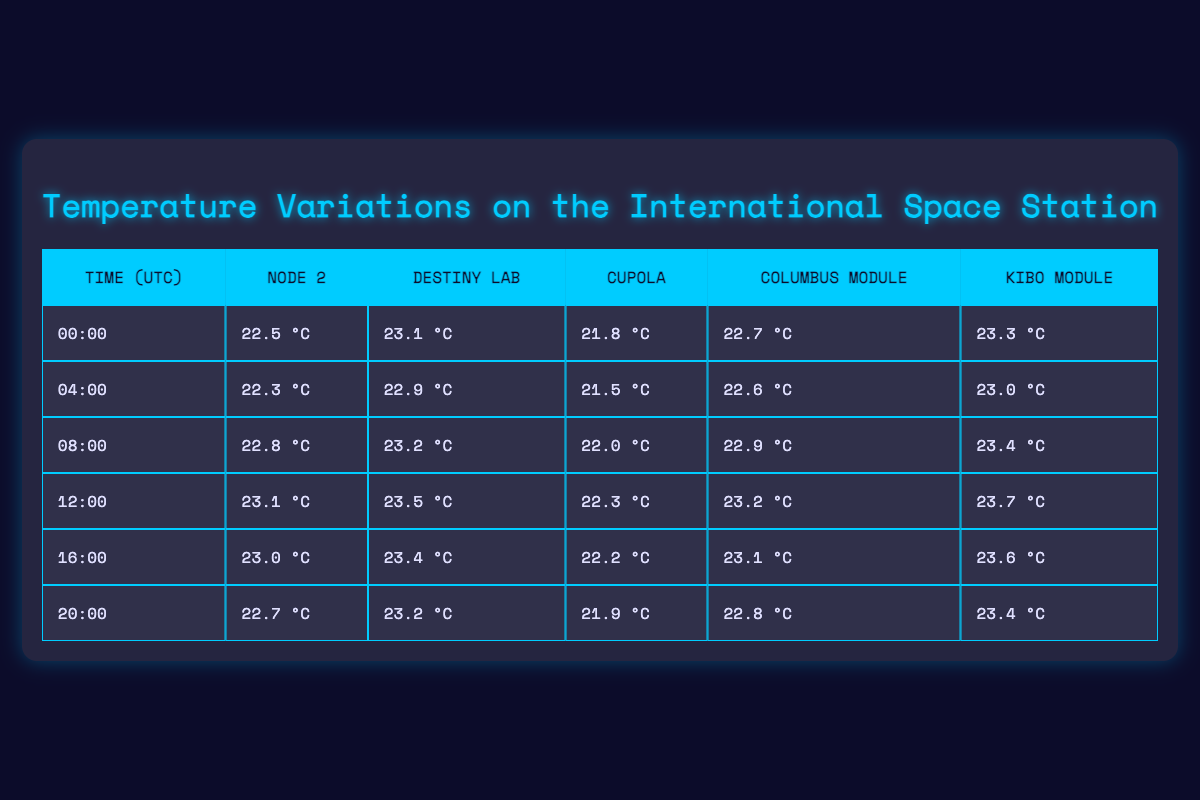What is the temperature in the Destiny Lab at 08:00? According to the table, the temperature in the Destiny Lab at 08:00 is 23.2 °C.
Answer: 23.2 °C Which module has the lowest temperature at 20:00? The table shows that at 20:00, the Cupola has the lowest temperature of 21.9 °C.
Answer: Cupola What is the average temperature in the Node 2 across all recorded times? Adding the Node 2 temperatures (22.5 + 22.3 + 22.8 + 23.1 + 23.0 + 22.7) equals 136.4 °C; with 6 data points, the average is 136.4/6 = 22.73 °C.
Answer: 22.73 °C Did the temperature in the Kibo Module ever exceed 23.5 °C? Looking at the Kibo Module temperatures, the recorded values are 23.3, 23.0, 23.4, 23.7, 23.6, and 23.4; thus, yes, it did exceed 23.5 °C.
Answer: Yes What was the largest temperature difference between the Columbus Module and the Cupola at any recorded time? Reviewing the differences: At 00:00 → 22.7 - 21.8 = 0.9; at 04:00 → 22.6 - 21.5 = 1.1; at 08:00 → 22.9 - 22.0 = 0.9; at 12:00 → 23.2 - 22.3 = 0.9; at 16:00 → 23.1 - 22.2 = 0.9; at 20:00 → 22.8 - 21.9 = 0.9. The largest difference is 1.1 °C at 04:00.
Answer: 1.1 °C Which module consistently has higher temperatures, the Cupola or the Kibo Module, throughout the 24-hour cycle? Comparing the temperatures, Kibo Module temperatures (23.3, 23.0, 23.4, 23.7, 23.6, 23.4) consistently exceed the Cupola temperatures (21.8, 21.5, 22.0, 22.3, 22.2, 21.9) at all times.
Answer: Kibo Module What is the time when the Node 2 temperature was the highest? The highest temperature recorded for Node 2 is 23.1 °C at 12:00.
Answer: 12:00 Is there a time when all modules recorded the same temperature? Checking through each time, no instances show all modules having the same temperature.
Answer: No 